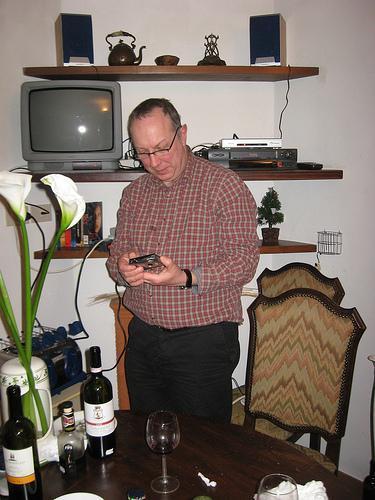How many people are in the picture?
Give a very brief answer. 1. 